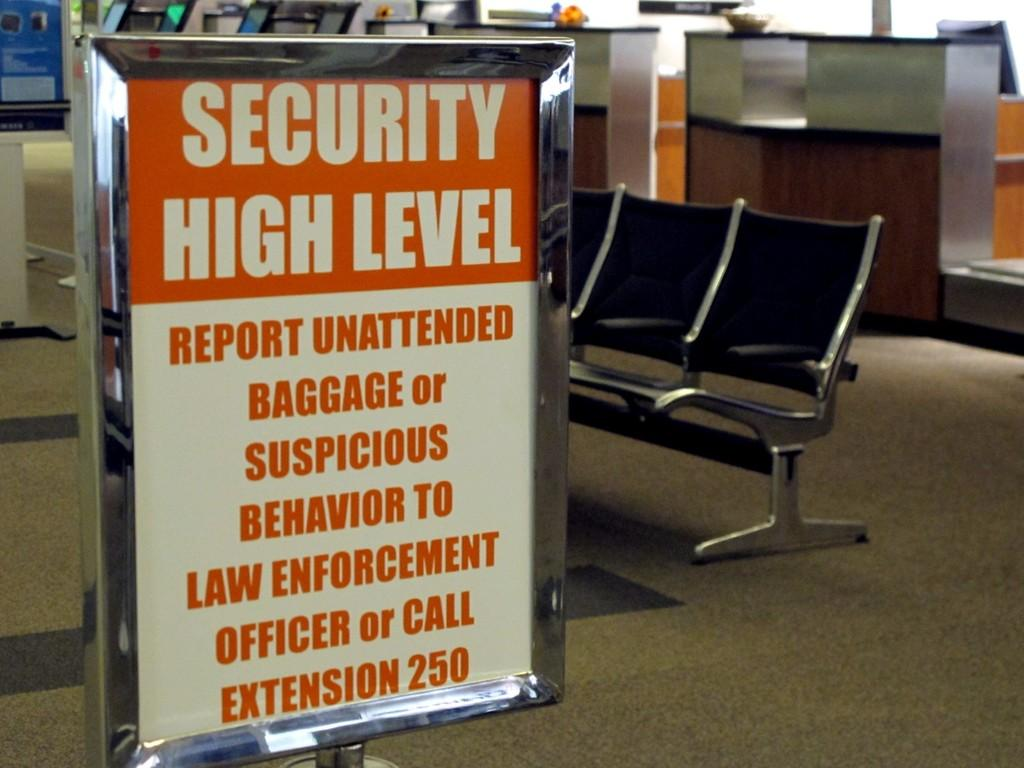<image>
Present a compact description of the photo's key features. A red and white sign in an airport that says Security High Level. 